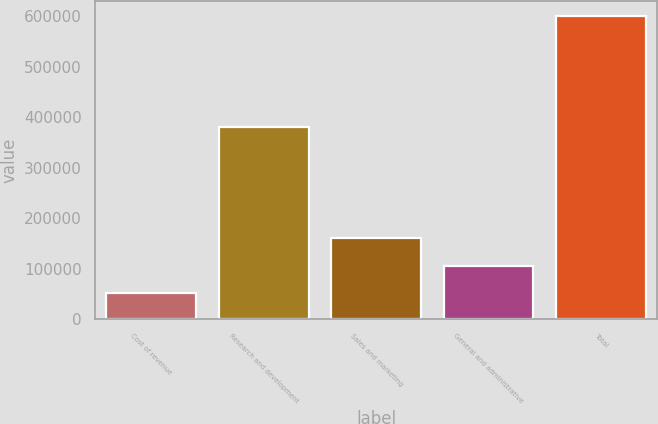<chart> <loc_0><loc_0><loc_500><loc_500><bar_chart><fcel>Cost of revenue<fcel>Research and development<fcel>Sales and marketing<fcel>General and administrative<fcel>Total<nl><fcel>50942<fcel>379913<fcel>160827<fcel>105884<fcel>600367<nl></chart> 